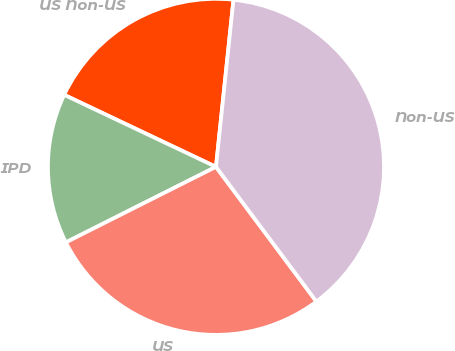Convert chart. <chart><loc_0><loc_0><loc_500><loc_500><pie_chart><fcel>US Non-US<fcel>IPD<fcel>US<fcel>Non-US<nl><fcel>19.61%<fcel>14.47%<fcel>27.78%<fcel>38.14%<nl></chart> 